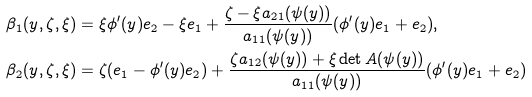Convert formula to latex. <formula><loc_0><loc_0><loc_500><loc_500>\beta _ { 1 } ( y , \zeta , \xi ) & = \xi \phi ^ { \prime } ( y ) e _ { 2 } - \xi e _ { 1 } + \frac { \zeta - \xi a _ { 2 1 } ( \psi ( y ) ) } { a _ { 1 1 } ( \psi ( y ) ) } ( \phi ^ { \prime } ( y ) e _ { 1 } + e _ { 2 } ) , \\ \beta _ { 2 } ( y , \zeta , \xi ) & = \zeta ( e _ { 1 } - \phi ^ { \prime } ( y ) e _ { 2 } ) + \frac { \zeta a _ { 1 2 } ( \psi ( y ) ) + \xi \det A ( \psi ( y ) ) } { a _ { 1 1 } ( \psi ( y ) ) } ( \phi ^ { \prime } ( y ) e _ { 1 } + e _ { 2 } )</formula> 